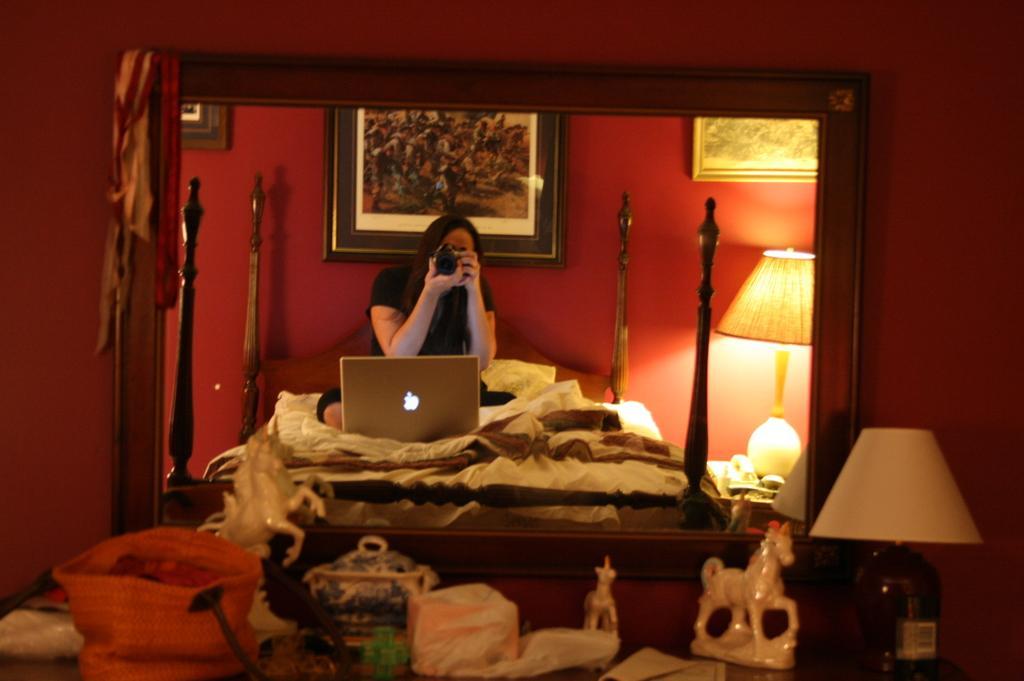In one or two sentences, can you explain what this image depicts? At the bottom of the image there is a table on which there are objects. There is a mirror in which there is a reflection of a woman. There is a laptop, bed, photo frame. In the background of the image there is wall. 